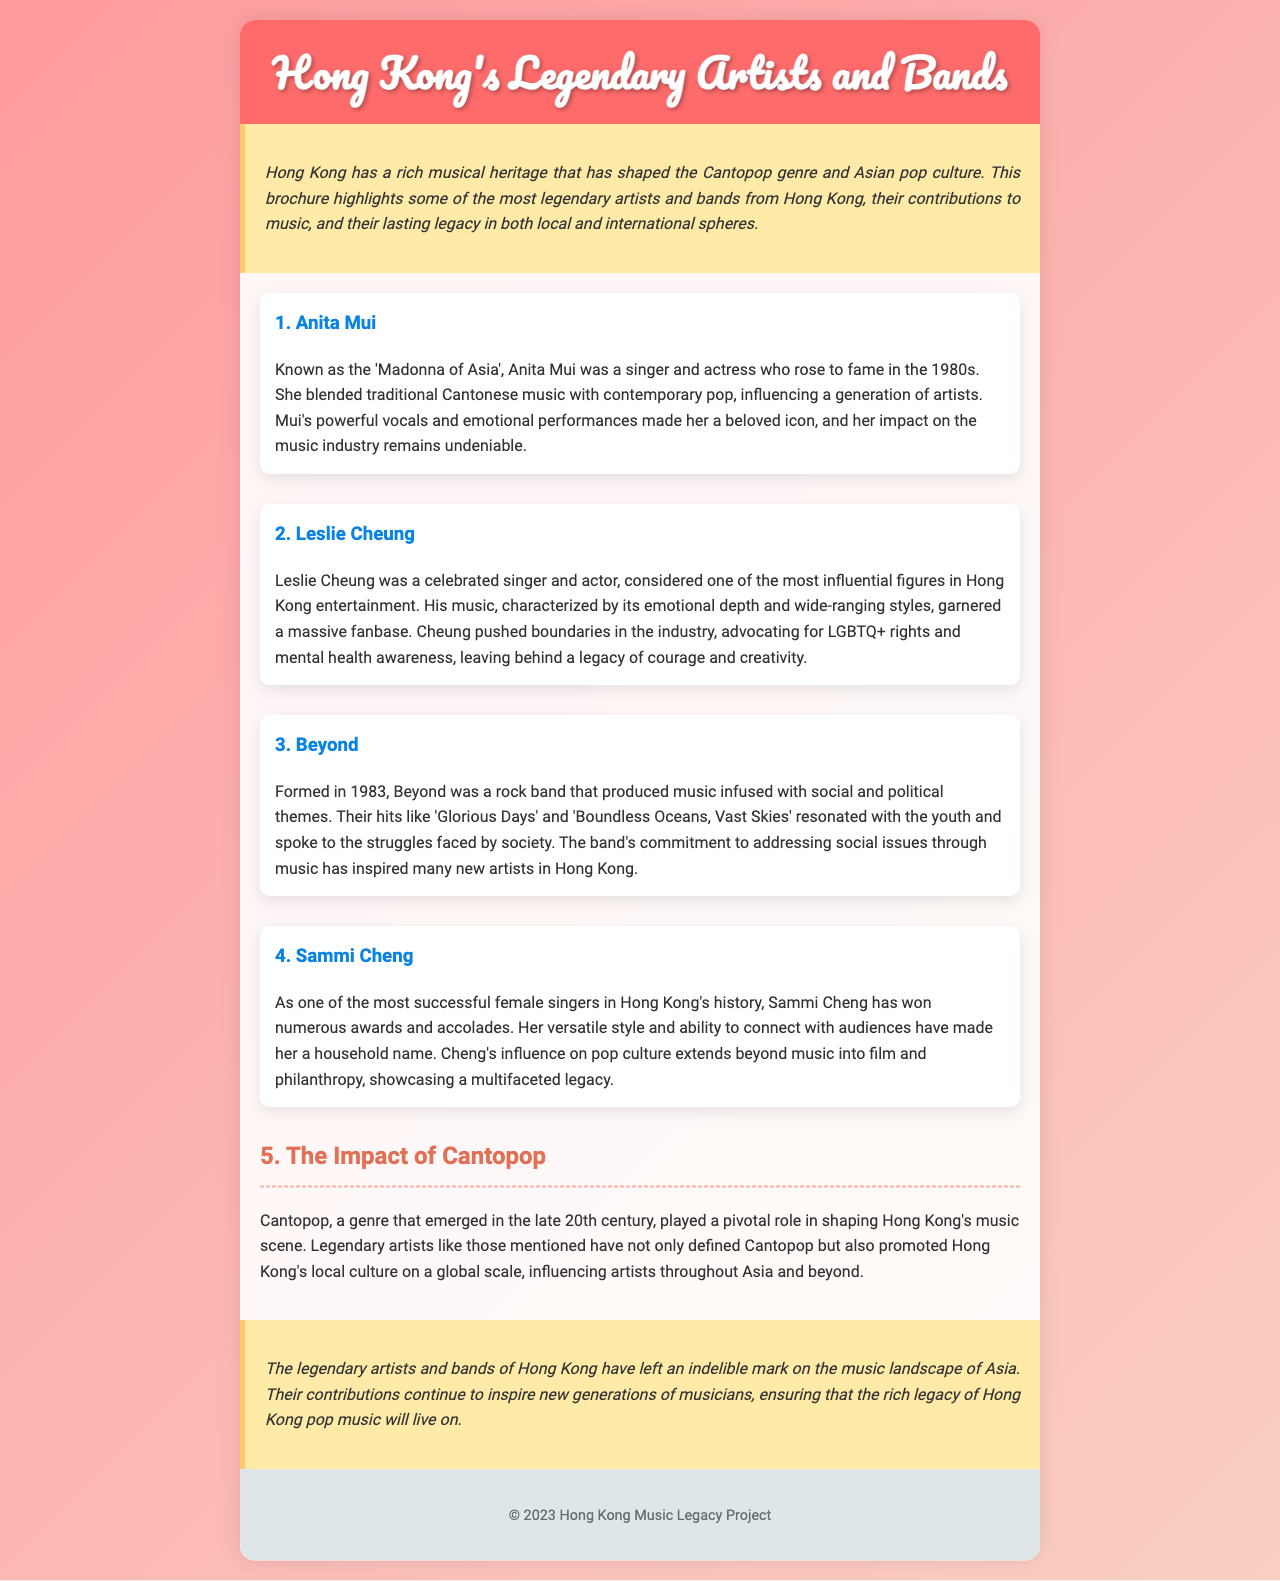What is the title of the document? The title of the document is presented prominently at the top of the page in the header section.
Answer: Hong Kong's Legendary Artists and Bands Who is known as the 'Madonna of Asia'? This information is mentioned in the section about the artist Anita Mui.
Answer: Anita Mui What year was Beyond formed? The document states the formation year of the band Beyond in its introduction.
Answer: 1983 What is Sammi Cheng recognized for? The document highlights Sammi Cheng's achievements and contributions in her specific section.
Answer: Successful female singer What themes does Beyond's music address? The document describes the nature and content of Beyond's music in terms of its social relevance.
Answer: Social and political themes Who pushed boundaries in the industry and advocated for LGBTQ+ rights? This information is part of the description of Leslie Cheung's contributions to music and society.
Answer: Leslie Cheung How has Cantopop impacted Hong Kong's music scene? The document reflects on the significance of Cantopop in the latter part, mentioning its influence.
Answer: Shaping Hong Kong's music scene Which artist's influence extends into philanthropy? The context provided on Sammi Cheng implies her influence goes beyond music.
Answer: Sammi Cheng What is the overall legacy of the artists mentioned? The conclusion summarizes the lasting impact of these artists.
Answer: Indelible mark on the music landscape 